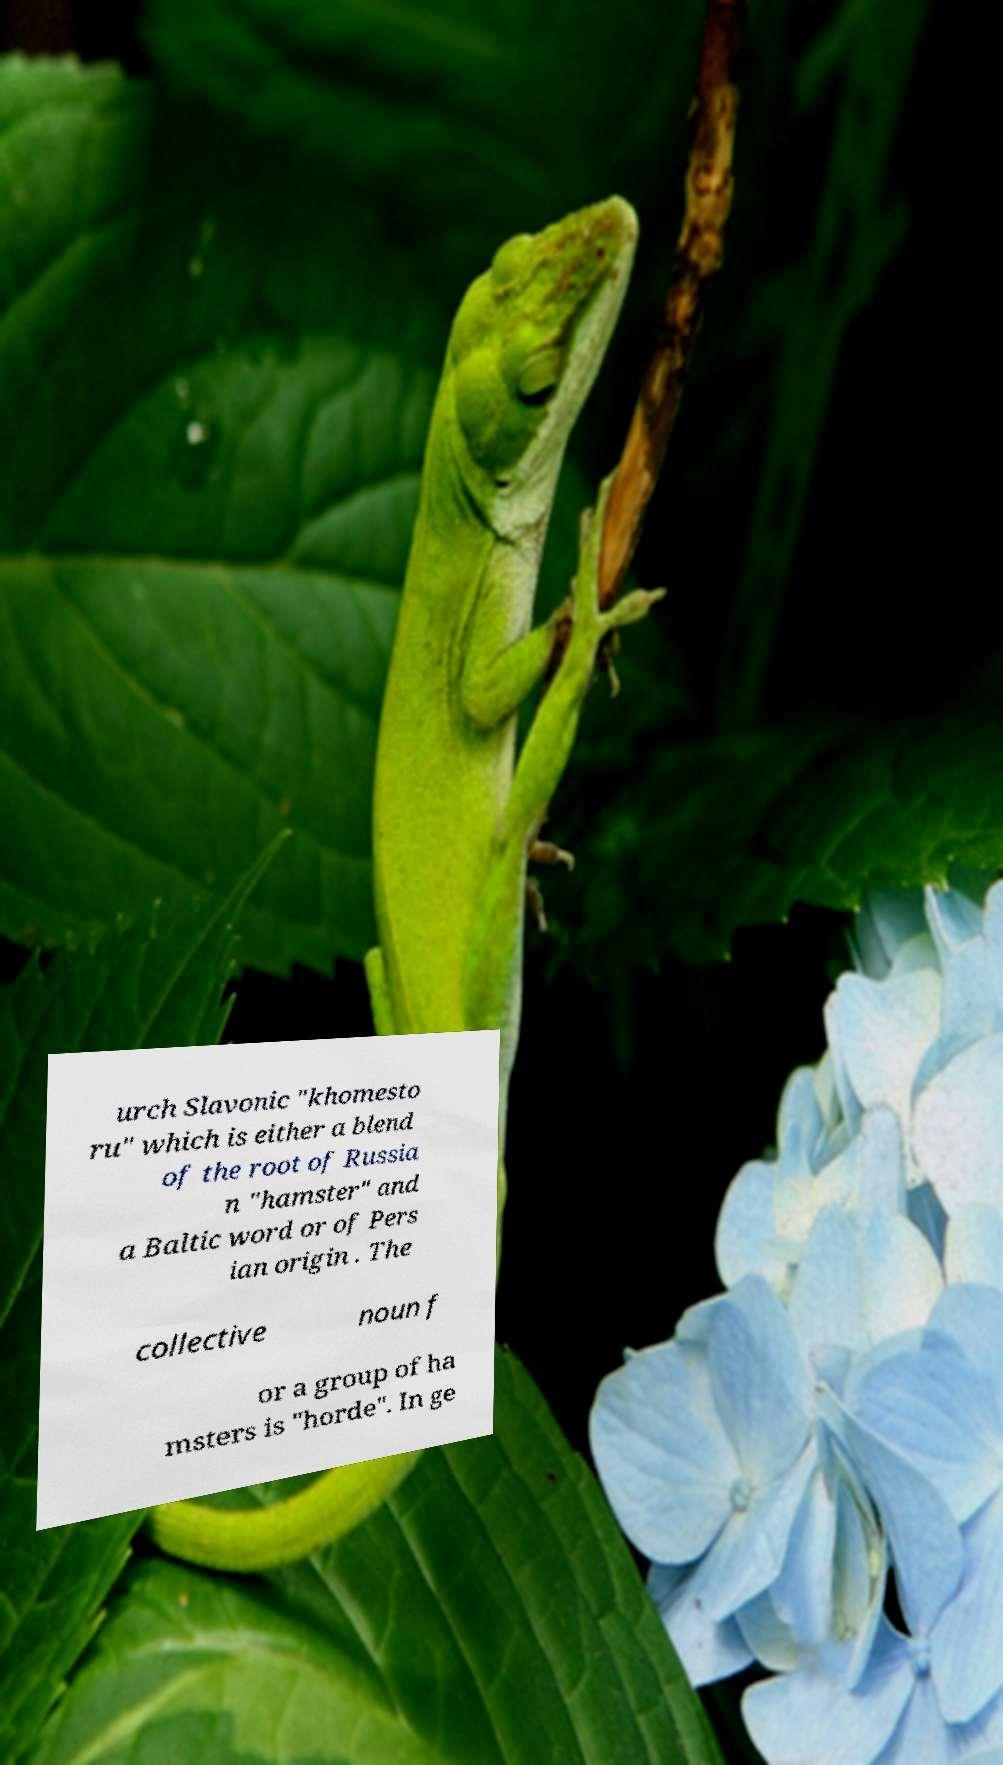There's text embedded in this image that I need extracted. Can you transcribe it verbatim? urch Slavonic "khomesto ru" which is either a blend of the root of Russia n "hamster" and a Baltic word or of Pers ian origin . The collective noun f or a group of ha msters is "horde". In ge 